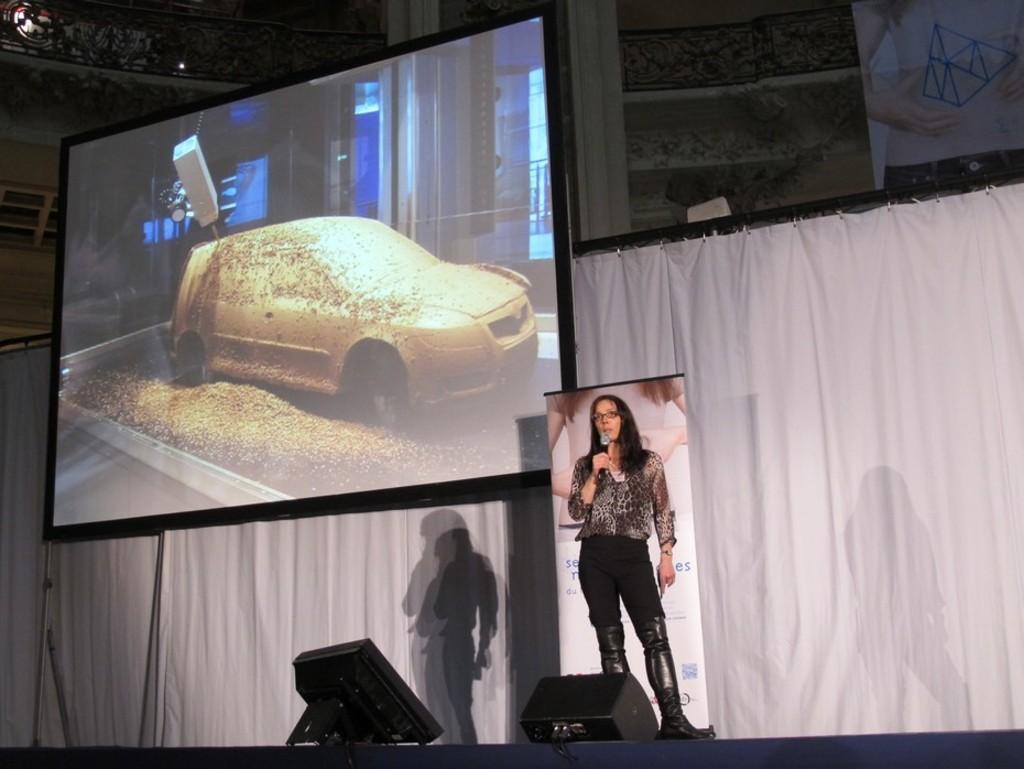Can you describe this image briefly? In the center of the image we can see a lady is standing and holding a mic and wearing spectacles. In the background of the image we can see a board, screen, curtain, wall. At the bottom of the image we can see the stage, on the stage we can see the lights. At the top of the image we can see the roof and lights. 